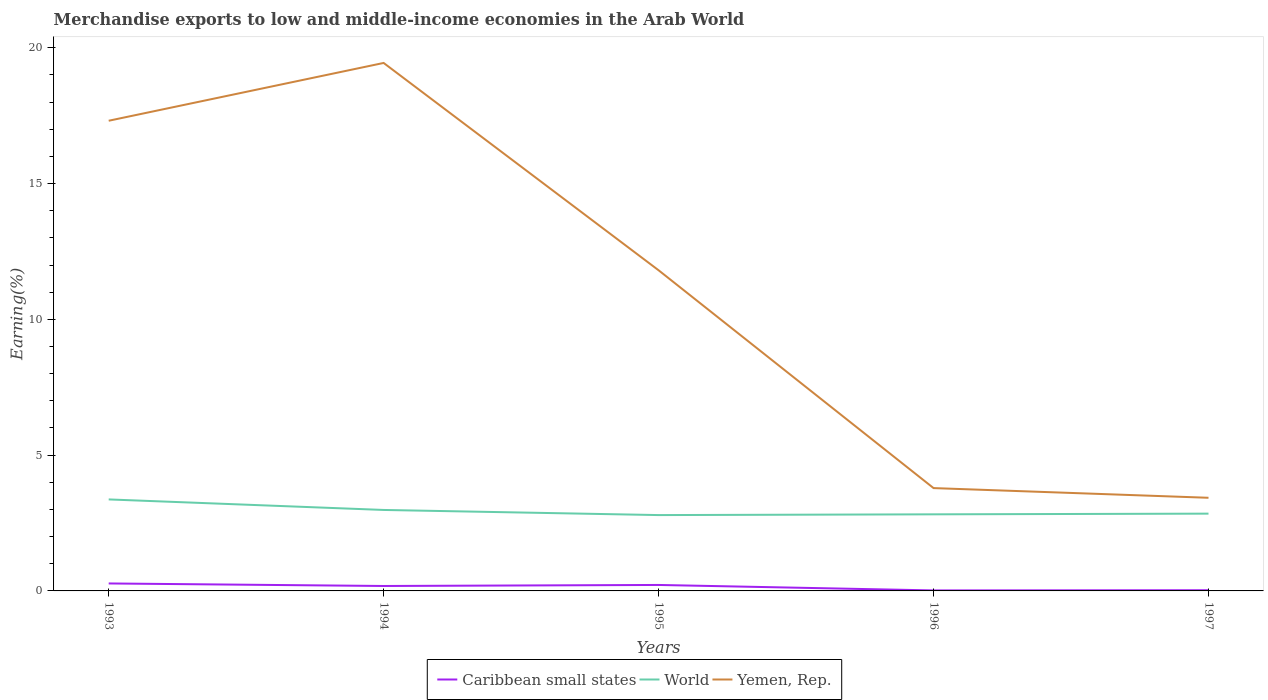Does the line corresponding to Yemen, Rep. intersect with the line corresponding to World?
Offer a very short reply. No. Is the number of lines equal to the number of legend labels?
Make the answer very short. Yes. Across all years, what is the maximum percentage of amount earned from merchandise exports in Caribbean small states?
Your response must be concise. 0.02. What is the total percentage of amount earned from merchandise exports in Yemen, Rep. in the graph?
Keep it short and to the point. 0.36. What is the difference between the highest and the second highest percentage of amount earned from merchandise exports in Yemen, Rep.?
Give a very brief answer. 16.01. What is the difference between the highest and the lowest percentage of amount earned from merchandise exports in World?
Give a very brief answer. 2. How many lines are there?
Your answer should be very brief. 3. Does the graph contain grids?
Make the answer very short. No. Where does the legend appear in the graph?
Provide a succinct answer. Bottom center. How are the legend labels stacked?
Offer a very short reply. Horizontal. What is the title of the graph?
Your answer should be very brief. Merchandise exports to low and middle-income economies in the Arab World. What is the label or title of the X-axis?
Provide a short and direct response. Years. What is the label or title of the Y-axis?
Make the answer very short. Earning(%). What is the Earning(%) in Caribbean small states in 1993?
Offer a terse response. 0.27. What is the Earning(%) of World in 1993?
Keep it short and to the point. 3.37. What is the Earning(%) in Yemen, Rep. in 1993?
Offer a terse response. 17.31. What is the Earning(%) in Caribbean small states in 1994?
Make the answer very short. 0.18. What is the Earning(%) of World in 1994?
Ensure brevity in your answer.  2.98. What is the Earning(%) in Yemen, Rep. in 1994?
Offer a very short reply. 19.44. What is the Earning(%) of Caribbean small states in 1995?
Offer a terse response. 0.22. What is the Earning(%) in World in 1995?
Your answer should be compact. 2.79. What is the Earning(%) in Yemen, Rep. in 1995?
Your response must be concise. 11.81. What is the Earning(%) of Caribbean small states in 1996?
Give a very brief answer. 0.02. What is the Earning(%) of World in 1996?
Ensure brevity in your answer.  2.82. What is the Earning(%) of Yemen, Rep. in 1996?
Your response must be concise. 3.79. What is the Earning(%) in Caribbean small states in 1997?
Give a very brief answer. 0.03. What is the Earning(%) in World in 1997?
Ensure brevity in your answer.  2.85. What is the Earning(%) of Yemen, Rep. in 1997?
Offer a terse response. 3.43. Across all years, what is the maximum Earning(%) in Caribbean small states?
Keep it short and to the point. 0.27. Across all years, what is the maximum Earning(%) in World?
Provide a short and direct response. 3.37. Across all years, what is the maximum Earning(%) in Yemen, Rep.?
Give a very brief answer. 19.44. Across all years, what is the minimum Earning(%) of Caribbean small states?
Ensure brevity in your answer.  0.02. Across all years, what is the minimum Earning(%) of World?
Give a very brief answer. 2.79. Across all years, what is the minimum Earning(%) in Yemen, Rep.?
Provide a succinct answer. 3.43. What is the total Earning(%) of Caribbean small states in the graph?
Your response must be concise. 0.72. What is the total Earning(%) in World in the graph?
Provide a short and direct response. 14.81. What is the total Earning(%) of Yemen, Rep. in the graph?
Your answer should be compact. 55.78. What is the difference between the Earning(%) of Caribbean small states in 1993 and that in 1994?
Offer a terse response. 0.09. What is the difference between the Earning(%) of World in 1993 and that in 1994?
Keep it short and to the point. 0.39. What is the difference between the Earning(%) of Yemen, Rep. in 1993 and that in 1994?
Your response must be concise. -2.13. What is the difference between the Earning(%) of Caribbean small states in 1993 and that in 1995?
Offer a very short reply. 0.06. What is the difference between the Earning(%) of World in 1993 and that in 1995?
Make the answer very short. 0.58. What is the difference between the Earning(%) in Yemen, Rep. in 1993 and that in 1995?
Your answer should be compact. 5.51. What is the difference between the Earning(%) in Caribbean small states in 1993 and that in 1996?
Provide a succinct answer. 0.26. What is the difference between the Earning(%) of World in 1993 and that in 1996?
Give a very brief answer. 0.55. What is the difference between the Earning(%) of Yemen, Rep. in 1993 and that in 1996?
Your answer should be compact. 13.53. What is the difference between the Earning(%) in Caribbean small states in 1993 and that in 1997?
Provide a short and direct response. 0.25. What is the difference between the Earning(%) in World in 1993 and that in 1997?
Your answer should be compact. 0.52. What is the difference between the Earning(%) of Yemen, Rep. in 1993 and that in 1997?
Offer a terse response. 13.88. What is the difference between the Earning(%) of Caribbean small states in 1994 and that in 1995?
Keep it short and to the point. -0.04. What is the difference between the Earning(%) in World in 1994 and that in 1995?
Ensure brevity in your answer.  0.19. What is the difference between the Earning(%) of Yemen, Rep. in 1994 and that in 1995?
Your answer should be very brief. 7.63. What is the difference between the Earning(%) in Caribbean small states in 1994 and that in 1996?
Make the answer very short. 0.16. What is the difference between the Earning(%) in World in 1994 and that in 1996?
Offer a terse response. 0.16. What is the difference between the Earning(%) of Yemen, Rep. in 1994 and that in 1996?
Provide a succinct answer. 15.65. What is the difference between the Earning(%) in Caribbean small states in 1994 and that in 1997?
Your answer should be compact. 0.16. What is the difference between the Earning(%) in World in 1994 and that in 1997?
Make the answer very short. 0.14. What is the difference between the Earning(%) in Yemen, Rep. in 1994 and that in 1997?
Your answer should be very brief. 16.01. What is the difference between the Earning(%) of Caribbean small states in 1995 and that in 1996?
Ensure brevity in your answer.  0.2. What is the difference between the Earning(%) in World in 1995 and that in 1996?
Your answer should be compact. -0.03. What is the difference between the Earning(%) in Yemen, Rep. in 1995 and that in 1996?
Ensure brevity in your answer.  8.02. What is the difference between the Earning(%) in Caribbean small states in 1995 and that in 1997?
Make the answer very short. 0.19. What is the difference between the Earning(%) of World in 1995 and that in 1997?
Your response must be concise. -0.05. What is the difference between the Earning(%) of Yemen, Rep. in 1995 and that in 1997?
Provide a short and direct response. 8.38. What is the difference between the Earning(%) in Caribbean small states in 1996 and that in 1997?
Offer a very short reply. -0.01. What is the difference between the Earning(%) of World in 1996 and that in 1997?
Make the answer very short. -0.03. What is the difference between the Earning(%) in Yemen, Rep. in 1996 and that in 1997?
Offer a terse response. 0.36. What is the difference between the Earning(%) of Caribbean small states in 1993 and the Earning(%) of World in 1994?
Make the answer very short. -2.71. What is the difference between the Earning(%) in Caribbean small states in 1993 and the Earning(%) in Yemen, Rep. in 1994?
Give a very brief answer. -19.17. What is the difference between the Earning(%) of World in 1993 and the Earning(%) of Yemen, Rep. in 1994?
Give a very brief answer. -16.07. What is the difference between the Earning(%) in Caribbean small states in 1993 and the Earning(%) in World in 1995?
Offer a very short reply. -2.52. What is the difference between the Earning(%) in Caribbean small states in 1993 and the Earning(%) in Yemen, Rep. in 1995?
Provide a short and direct response. -11.53. What is the difference between the Earning(%) in World in 1993 and the Earning(%) in Yemen, Rep. in 1995?
Offer a very short reply. -8.44. What is the difference between the Earning(%) in Caribbean small states in 1993 and the Earning(%) in World in 1996?
Offer a terse response. -2.55. What is the difference between the Earning(%) in Caribbean small states in 1993 and the Earning(%) in Yemen, Rep. in 1996?
Offer a very short reply. -3.51. What is the difference between the Earning(%) in World in 1993 and the Earning(%) in Yemen, Rep. in 1996?
Make the answer very short. -0.42. What is the difference between the Earning(%) of Caribbean small states in 1993 and the Earning(%) of World in 1997?
Offer a very short reply. -2.57. What is the difference between the Earning(%) of Caribbean small states in 1993 and the Earning(%) of Yemen, Rep. in 1997?
Your response must be concise. -3.15. What is the difference between the Earning(%) of World in 1993 and the Earning(%) of Yemen, Rep. in 1997?
Your answer should be compact. -0.06. What is the difference between the Earning(%) in Caribbean small states in 1994 and the Earning(%) in World in 1995?
Offer a terse response. -2.61. What is the difference between the Earning(%) of Caribbean small states in 1994 and the Earning(%) of Yemen, Rep. in 1995?
Offer a very short reply. -11.62. What is the difference between the Earning(%) in World in 1994 and the Earning(%) in Yemen, Rep. in 1995?
Your answer should be very brief. -8.82. What is the difference between the Earning(%) in Caribbean small states in 1994 and the Earning(%) in World in 1996?
Your response must be concise. -2.64. What is the difference between the Earning(%) of Caribbean small states in 1994 and the Earning(%) of Yemen, Rep. in 1996?
Make the answer very short. -3.6. What is the difference between the Earning(%) of World in 1994 and the Earning(%) of Yemen, Rep. in 1996?
Keep it short and to the point. -0.81. What is the difference between the Earning(%) of Caribbean small states in 1994 and the Earning(%) of World in 1997?
Your answer should be compact. -2.66. What is the difference between the Earning(%) in Caribbean small states in 1994 and the Earning(%) in Yemen, Rep. in 1997?
Offer a very short reply. -3.25. What is the difference between the Earning(%) of World in 1994 and the Earning(%) of Yemen, Rep. in 1997?
Provide a succinct answer. -0.45. What is the difference between the Earning(%) of Caribbean small states in 1995 and the Earning(%) of World in 1996?
Your answer should be very brief. -2.6. What is the difference between the Earning(%) in Caribbean small states in 1995 and the Earning(%) in Yemen, Rep. in 1996?
Give a very brief answer. -3.57. What is the difference between the Earning(%) of World in 1995 and the Earning(%) of Yemen, Rep. in 1996?
Keep it short and to the point. -0.99. What is the difference between the Earning(%) of Caribbean small states in 1995 and the Earning(%) of World in 1997?
Give a very brief answer. -2.63. What is the difference between the Earning(%) in Caribbean small states in 1995 and the Earning(%) in Yemen, Rep. in 1997?
Your response must be concise. -3.21. What is the difference between the Earning(%) of World in 1995 and the Earning(%) of Yemen, Rep. in 1997?
Offer a very short reply. -0.64. What is the difference between the Earning(%) of Caribbean small states in 1996 and the Earning(%) of World in 1997?
Make the answer very short. -2.83. What is the difference between the Earning(%) in Caribbean small states in 1996 and the Earning(%) in Yemen, Rep. in 1997?
Ensure brevity in your answer.  -3.41. What is the difference between the Earning(%) of World in 1996 and the Earning(%) of Yemen, Rep. in 1997?
Provide a succinct answer. -0.61. What is the average Earning(%) of Caribbean small states per year?
Your answer should be very brief. 0.14. What is the average Earning(%) in World per year?
Keep it short and to the point. 2.96. What is the average Earning(%) of Yemen, Rep. per year?
Your response must be concise. 11.16. In the year 1993, what is the difference between the Earning(%) in Caribbean small states and Earning(%) in World?
Your answer should be very brief. -3.09. In the year 1993, what is the difference between the Earning(%) of Caribbean small states and Earning(%) of Yemen, Rep.?
Your response must be concise. -17.04. In the year 1993, what is the difference between the Earning(%) of World and Earning(%) of Yemen, Rep.?
Your answer should be compact. -13.94. In the year 1994, what is the difference between the Earning(%) of Caribbean small states and Earning(%) of World?
Your answer should be very brief. -2.8. In the year 1994, what is the difference between the Earning(%) in Caribbean small states and Earning(%) in Yemen, Rep.?
Provide a short and direct response. -19.26. In the year 1994, what is the difference between the Earning(%) in World and Earning(%) in Yemen, Rep.?
Ensure brevity in your answer.  -16.46. In the year 1995, what is the difference between the Earning(%) in Caribbean small states and Earning(%) in World?
Your answer should be compact. -2.57. In the year 1995, what is the difference between the Earning(%) of Caribbean small states and Earning(%) of Yemen, Rep.?
Ensure brevity in your answer.  -11.59. In the year 1995, what is the difference between the Earning(%) in World and Earning(%) in Yemen, Rep.?
Ensure brevity in your answer.  -9.01. In the year 1996, what is the difference between the Earning(%) of Caribbean small states and Earning(%) of World?
Give a very brief answer. -2.8. In the year 1996, what is the difference between the Earning(%) of Caribbean small states and Earning(%) of Yemen, Rep.?
Offer a very short reply. -3.77. In the year 1996, what is the difference between the Earning(%) of World and Earning(%) of Yemen, Rep.?
Provide a short and direct response. -0.97. In the year 1997, what is the difference between the Earning(%) in Caribbean small states and Earning(%) in World?
Keep it short and to the point. -2.82. In the year 1997, what is the difference between the Earning(%) in Caribbean small states and Earning(%) in Yemen, Rep.?
Make the answer very short. -3.4. In the year 1997, what is the difference between the Earning(%) in World and Earning(%) in Yemen, Rep.?
Provide a short and direct response. -0.58. What is the ratio of the Earning(%) in Caribbean small states in 1993 to that in 1994?
Give a very brief answer. 1.51. What is the ratio of the Earning(%) of World in 1993 to that in 1994?
Keep it short and to the point. 1.13. What is the ratio of the Earning(%) in Yemen, Rep. in 1993 to that in 1994?
Ensure brevity in your answer.  0.89. What is the ratio of the Earning(%) of Caribbean small states in 1993 to that in 1995?
Offer a very short reply. 1.25. What is the ratio of the Earning(%) in World in 1993 to that in 1995?
Your response must be concise. 1.21. What is the ratio of the Earning(%) in Yemen, Rep. in 1993 to that in 1995?
Provide a short and direct response. 1.47. What is the ratio of the Earning(%) of Caribbean small states in 1993 to that in 1996?
Ensure brevity in your answer.  14.92. What is the ratio of the Earning(%) in World in 1993 to that in 1996?
Ensure brevity in your answer.  1.19. What is the ratio of the Earning(%) in Yemen, Rep. in 1993 to that in 1996?
Keep it short and to the point. 4.57. What is the ratio of the Earning(%) in Caribbean small states in 1993 to that in 1997?
Your answer should be very brief. 10.53. What is the ratio of the Earning(%) of World in 1993 to that in 1997?
Make the answer very short. 1.18. What is the ratio of the Earning(%) in Yemen, Rep. in 1993 to that in 1997?
Provide a succinct answer. 5.05. What is the ratio of the Earning(%) of Caribbean small states in 1994 to that in 1995?
Offer a very short reply. 0.83. What is the ratio of the Earning(%) of World in 1994 to that in 1995?
Give a very brief answer. 1.07. What is the ratio of the Earning(%) of Yemen, Rep. in 1994 to that in 1995?
Your answer should be compact. 1.65. What is the ratio of the Earning(%) in Caribbean small states in 1994 to that in 1996?
Ensure brevity in your answer.  9.88. What is the ratio of the Earning(%) of World in 1994 to that in 1996?
Provide a short and direct response. 1.06. What is the ratio of the Earning(%) in Yemen, Rep. in 1994 to that in 1996?
Ensure brevity in your answer.  5.13. What is the ratio of the Earning(%) of Caribbean small states in 1994 to that in 1997?
Your response must be concise. 6.97. What is the ratio of the Earning(%) in World in 1994 to that in 1997?
Provide a short and direct response. 1.05. What is the ratio of the Earning(%) of Yemen, Rep. in 1994 to that in 1997?
Your answer should be very brief. 5.67. What is the ratio of the Earning(%) of Caribbean small states in 1995 to that in 1996?
Keep it short and to the point. 11.93. What is the ratio of the Earning(%) of World in 1995 to that in 1996?
Give a very brief answer. 0.99. What is the ratio of the Earning(%) of Yemen, Rep. in 1995 to that in 1996?
Give a very brief answer. 3.12. What is the ratio of the Earning(%) in Caribbean small states in 1995 to that in 1997?
Keep it short and to the point. 8.42. What is the ratio of the Earning(%) of World in 1995 to that in 1997?
Ensure brevity in your answer.  0.98. What is the ratio of the Earning(%) in Yemen, Rep. in 1995 to that in 1997?
Ensure brevity in your answer.  3.44. What is the ratio of the Earning(%) of Caribbean small states in 1996 to that in 1997?
Your answer should be compact. 0.71. What is the ratio of the Earning(%) of Yemen, Rep. in 1996 to that in 1997?
Provide a succinct answer. 1.1. What is the difference between the highest and the second highest Earning(%) in Caribbean small states?
Give a very brief answer. 0.06. What is the difference between the highest and the second highest Earning(%) of World?
Offer a terse response. 0.39. What is the difference between the highest and the second highest Earning(%) in Yemen, Rep.?
Offer a terse response. 2.13. What is the difference between the highest and the lowest Earning(%) of Caribbean small states?
Your answer should be very brief. 0.26. What is the difference between the highest and the lowest Earning(%) of World?
Offer a terse response. 0.58. What is the difference between the highest and the lowest Earning(%) in Yemen, Rep.?
Keep it short and to the point. 16.01. 